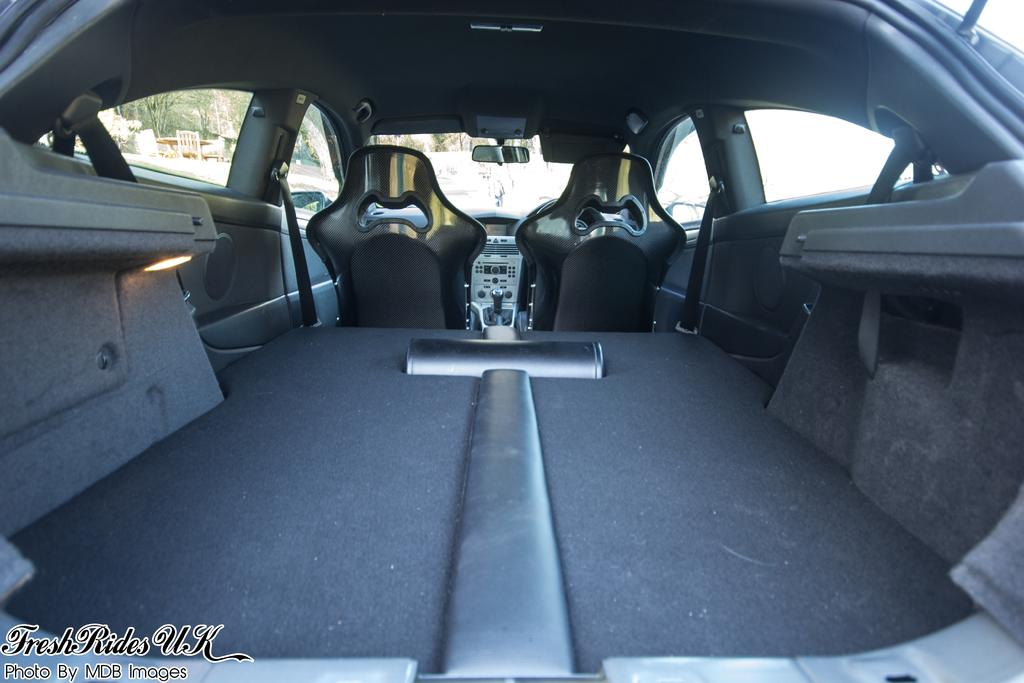What is the perspective of the image? The image is taken from inside a car. What part of the car can be seen in the image? There are mirrors of the car visible in the image. How many seats are visible in the car? There are two seats in the car. What is visible through the car window? Trees and the sky are visible through the car window. How many pages are visible in the image? There are no pages present in the image; it is taken from inside a car. What type of nail is being hammered into the car in the image? There is no nail being hammered into the car in the image. 